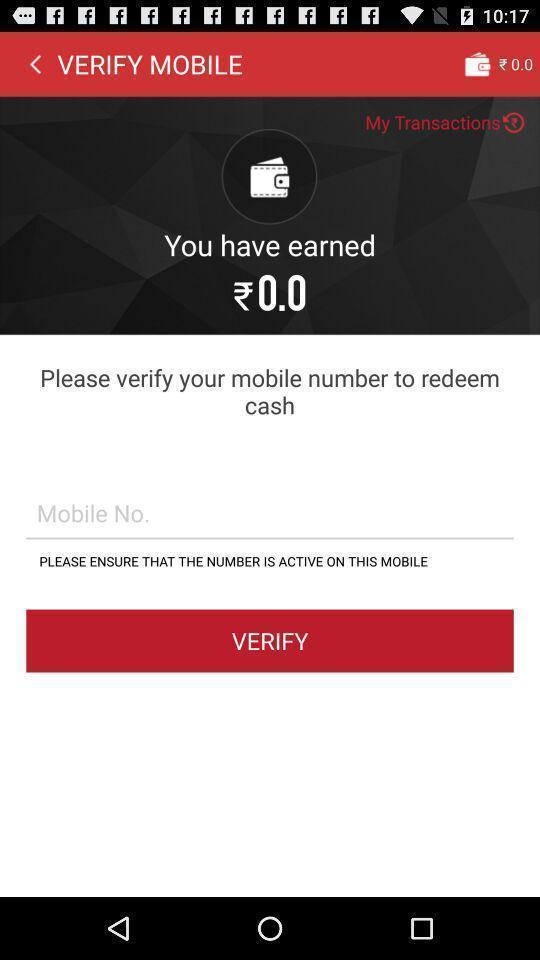Tell me what you see in this picture. Page to verify contact number in the payment app. 